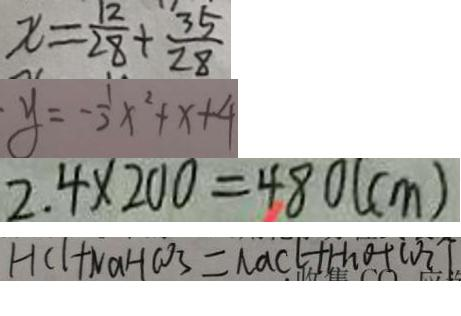<formula> <loc_0><loc_0><loc_500><loc_500>x = \frac { 1 2 } { 2 8 } + \frac { 3 5 } { 2 8 } 
 y = - \frac { 1 } { 2 } x ^ { 2 } + x + 4 
 2 . 4 \times 2 0 0 = 4 8 0 ( c m ) 
 H C l + N a H C O _ { 3 } = N a C l + H _ { 2 } O + C O _ { 2 } \uparrow</formula> 